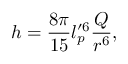Convert formula to latex. <formula><loc_0><loc_0><loc_500><loc_500>h = \frac { 8 \pi } { 1 5 } l _ { p } ^ { \prime 6 } \frac { Q } { r ^ { 6 } } ,</formula> 